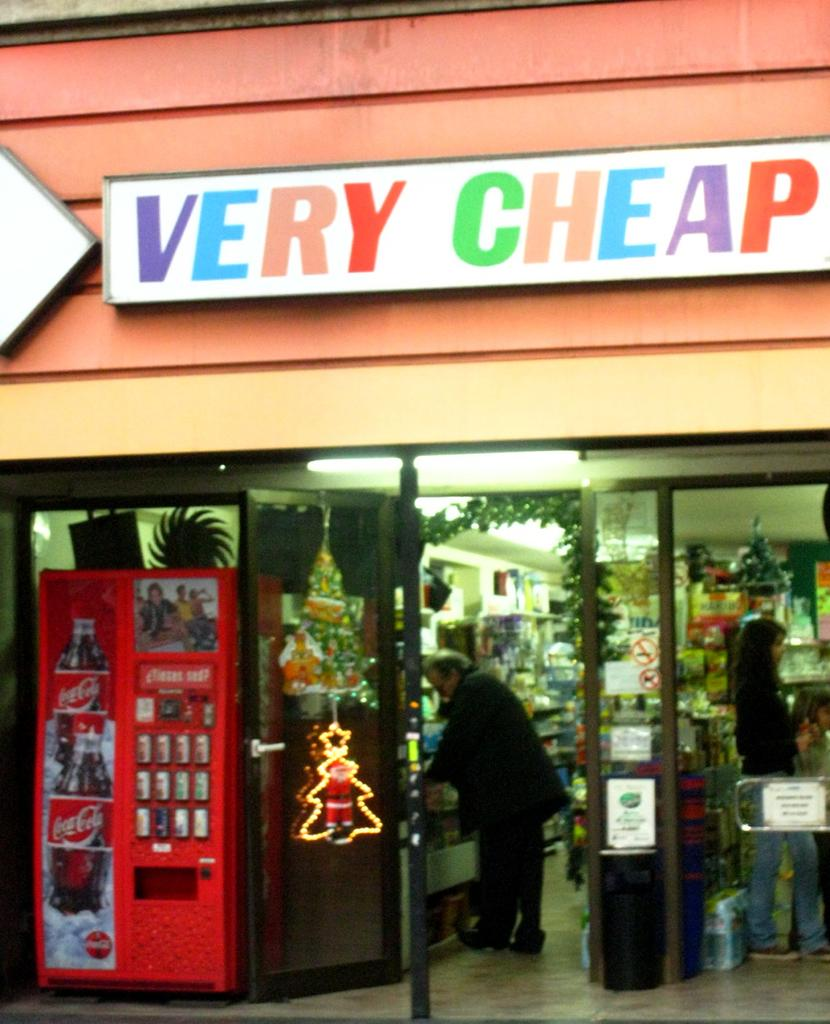What type of establishment is shown in the image? There is a shop in the image. What can be seen inside the shop? There are many objects visible inside the shop. How many people are inside the shop? Two people are standing inside the shop. What is attached to the exterior of the shop? There are boards attached to the shop. What is located to the left of the shop? There is a machine to the left of the shop. What type of dirt can be seen covering the houses in the image? There are no houses present in the image, and therefore no dirt can be observed. What type of cannon is visible in the image? There is no cannon present in the image. 